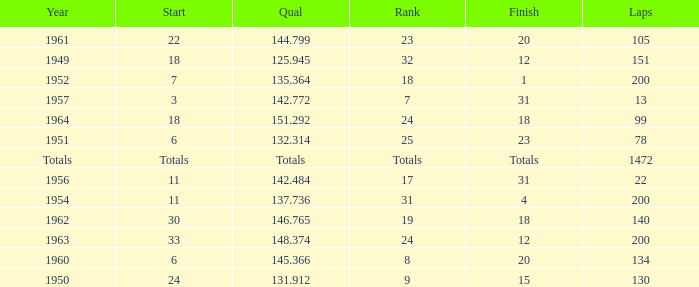Name the rank with laps of 200 and qual of 148.374 24.0. 